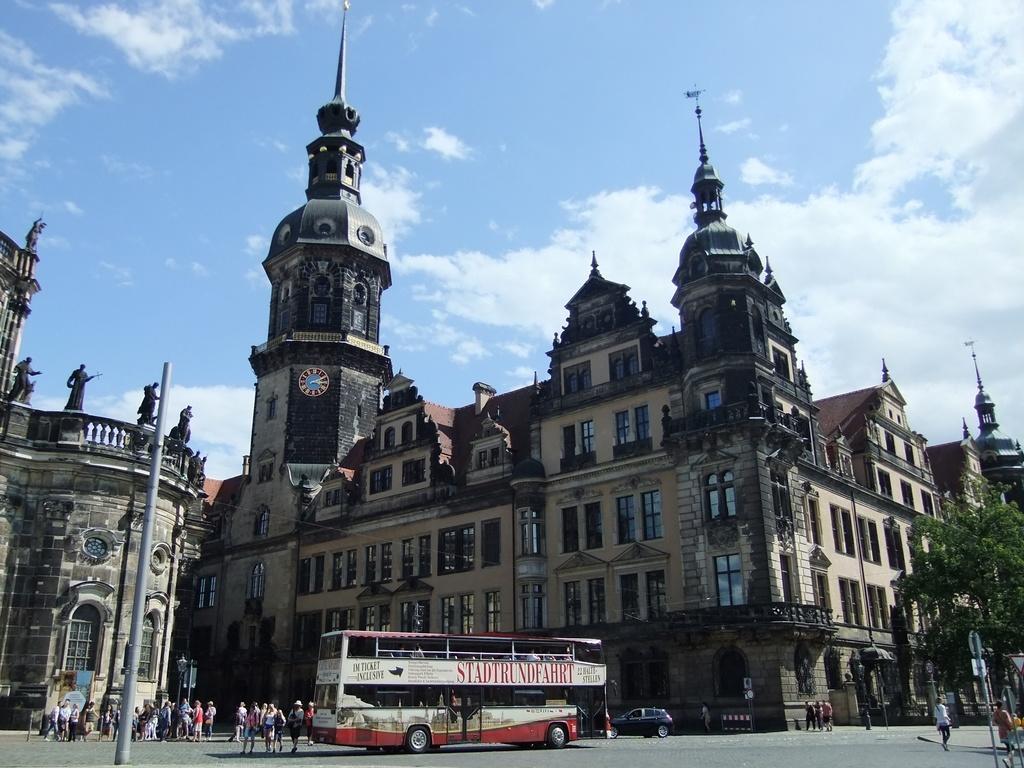Please provide a concise description of this image. In this image I can see at the bottom there is the double Decker bus. On the left side there are few people on the road, at the back side there are big buildings. On the right side there is a tree, at the top there is the sky in blue color. 